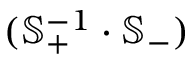<formula> <loc_0><loc_0><loc_500><loc_500>( \mathbb { S } _ { + } ^ { - 1 } \cdot \mathbb { S } _ { - } )</formula> 